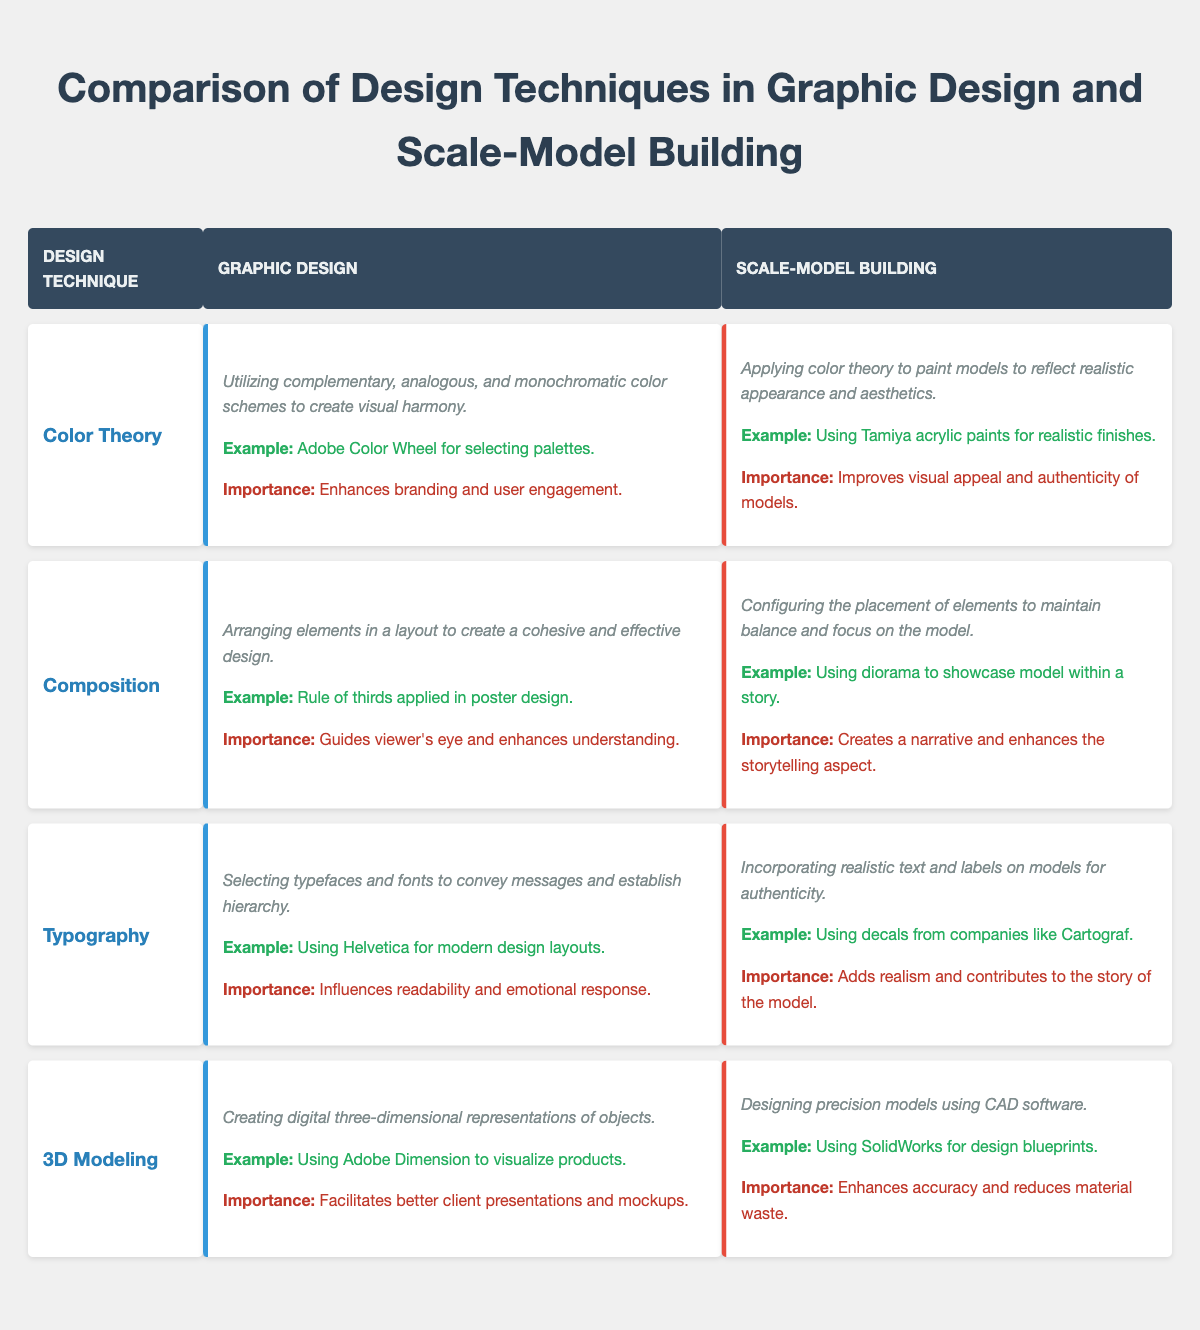What is the importance of Color Theory in graphic design? The table states that the importance of Color Theory in graphic design is to enhance branding and user engagement. This can be found in the "importance" section of the graphic design column under Color Theory.
Answer: Enhances branding and user engagement What example is given for Composition in graphic design? According to the table, the example provided for Composition in graphic design is the application of the rule of thirds in poster design. This information is listed in the example section of the graphic design column for Composition.
Answer: Rule of thirds applied in poster design Is Typography important for authenticity in scale-model building? The table specifies that the importance of Typography in scale-model building is to add realism and contribute to the story of the model. Thus, it indicates that Typography does play a significant role in authenticity, making this statement true.
Answer: Yes Which design technique has a description related to arranging elements for a cohesive design? The technique that relates to arranging elements for a cohesive design is Composition, as noted in the description section of the graphic design column for this technique.
Answer: Composition In terms of importance, which design technique focuses on enhancing visual appeal and authenticity? The table indicates that the design technique Color Theory in scale-model building focuses on enhancing visual appeal and authenticity. This is found in the importance section of the scale-model building column under Color Theory.
Answer: Color Theory What technique is associated with using CAD software in scale-model building? The table demonstrates that the technique associated with using CAD software in scale-model building is 3D Modeling, as noted in the description section of the scale-model building column for that technique.
Answer: 3D Modeling Which design technique uses Adobe Color Wheel as an example? The table shows that the example of using Adobe Color Wheel is linked to the design technique Color Theory in the graphic design column. This information can be found in the example section under Color Theory.
Answer: Color Theory What do both graphic design and scale-model building techniques share in focusing on visual appeal? Both graphic design and scale-model building techniques share Color Theory as a common focus for visual appeal. In graphic design, it enhances branding and user engagement, while in scale-model building, it improves visual appeal and authenticity. This can be deduced by looking at the Color Theory row in both columns of the table.
Answer: Color Theory 